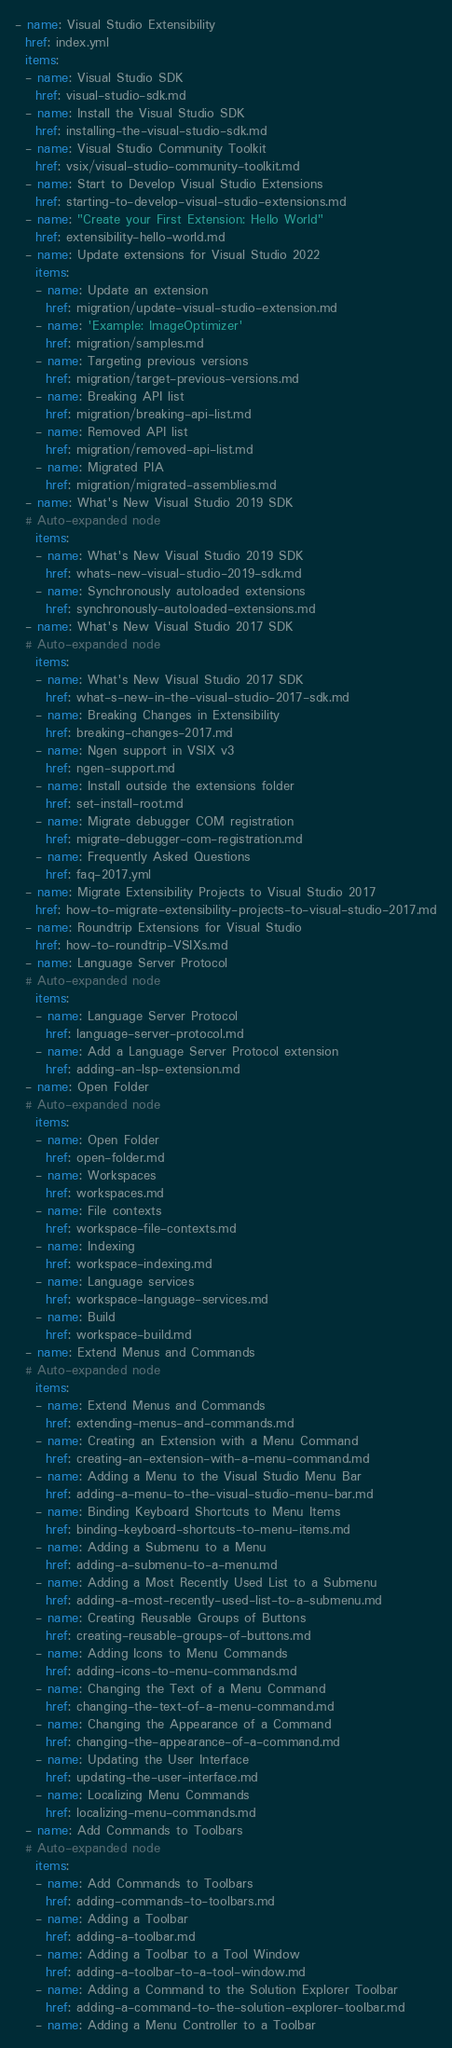Convert code to text. <code><loc_0><loc_0><loc_500><loc_500><_YAML_>- name: Visual Studio Extensibility
  href: index.yml
  items:
  - name: Visual Studio SDK
    href: visual-studio-sdk.md
  - name: Install the Visual Studio SDK
    href: installing-the-visual-studio-sdk.md
  - name: Visual Studio Community Toolkit
    href: vsix/visual-studio-community-toolkit.md
  - name: Start to Develop Visual Studio Extensions
    href: starting-to-develop-visual-studio-extensions.md
  - name: "Create your First Extension: Hello World"
    href: extensibility-hello-world.md
  - name: Update extensions for Visual Studio 2022
    items:
    - name: Update an extension
      href: migration/update-visual-studio-extension.md
    - name: 'Example: ImageOptimizer'
      href: migration/samples.md
    - name: Targeting previous versions
      href: migration/target-previous-versions.md
    - name: Breaking API list
      href: migration/breaking-api-list.md
    - name: Removed API list
      href: migration/removed-api-list.md
    - name: Migrated PIA
      href: migration/migrated-assemblies.md
  - name: What's New Visual Studio 2019 SDK
  # Auto-expanded node
    items:
    - name: What's New Visual Studio 2019 SDK
      href: whats-new-visual-studio-2019-sdk.md
    - name: Synchronously autoloaded extensions
      href: synchronously-autoloaded-extensions.md
  - name: What's New Visual Studio 2017 SDK
  # Auto-expanded node
    items:
    - name: What's New Visual Studio 2017 SDK
      href: what-s-new-in-the-visual-studio-2017-sdk.md
    - name: Breaking Changes in Extensibility
      href: breaking-changes-2017.md
    - name: Ngen support in VSIX v3
      href: ngen-support.md
    - name: Install outside the extensions folder
      href: set-install-root.md
    - name: Migrate debugger COM registration
      href: migrate-debugger-com-registration.md
    - name: Frequently Asked Questions
      href: faq-2017.yml
  - name: Migrate Extensibility Projects to Visual Studio 2017
    href: how-to-migrate-extensibility-projects-to-visual-studio-2017.md
  - name: Roundtrip Extensions for Visual Studio
    href: how-to-roundtrip-VSIXs.md
  - name: Language Server Protocol
  # Auto-expanded node
    items:
    - name: Language Server Protocol
      href: language-server-protocol.md
    - name: Add a Language Server Protocol extension
      href: adding-an-lsp-extension.md
  - name: Open Folder
  # Auto-expanded node
    items:
    - name: Open Folder
      href: open-folder.md
    - name: Workspaces
      href: workspaces.md
    - name: File contexts
      href: workspace-file-contexts.md
    - name: Indexing
      href: workspace-indexing.md
    - name: Language services
      href: workspace-language-services.md
    - name: Build
      href: workspace-build.md
  - name: Extend Menus and Commands
  # Auto-expanded node
    items:
    - name: Extend Menus and Commands
      href: extending-menus-and-commands.md
    - name: Creating an Extension with a Menu Command
      href: creating-an-extension-with-a-menu-command.md
    - name: Adding a Menu to the Visual Studio Menu Bar
      href: adding-a-menu-to-the-visual-studio-menu-bar.md
    - name: Binding Keyboard Shortcuts to Menu Items
      href: binding-keyboard-shortcuts-to-menu-items.md
    - name: Adding a Submenu to a Menu
      href: adding-a-submenu-to-a-menu.md
    - name: Adding a Most Recently Used List to a Submenu
      href: adding-a-most-recently-used-list-to-a-submenu.md
    - name: Creating Reusable Groups of Buttons
      href: creating-reusable-groups-of-buttons.md
    - name: Adding Icons to Menu Commands
      href: adding-icons-to-menu-commands.md
    - name: Changing the Text of a Menu Command
      href: changing-the-text-of-a-menu-command.md
    - name: Changing the Appearance of a Command
      href: changing-the-appearance-of-a-command.md
    - name: Updating the User Interface
      href: updating-the-user-interface.md
    - name: Localizing Menu Commands
      href: localizing-menu-commands.md
  - name: Add Commands to Toolbars
  # Auto-expanded node
    items:
    - name: Add Commands to Toolbars
      href: adding-commands-to-toolbars.md
    - name: Adding a Toolbar
      href: adding-a-toolbar.md
    - name: Adding a Toolbar to a Tool Window
      href: adding-a-toolbar-to-a-tool-window.md
    - name: Adding a Command to the Solution Explorer Toolbar
      href: adding-a-command-to-the-solution-explorer-toolbar.md
    - name: Adding a Menu Controller to a Toolbar</code> 